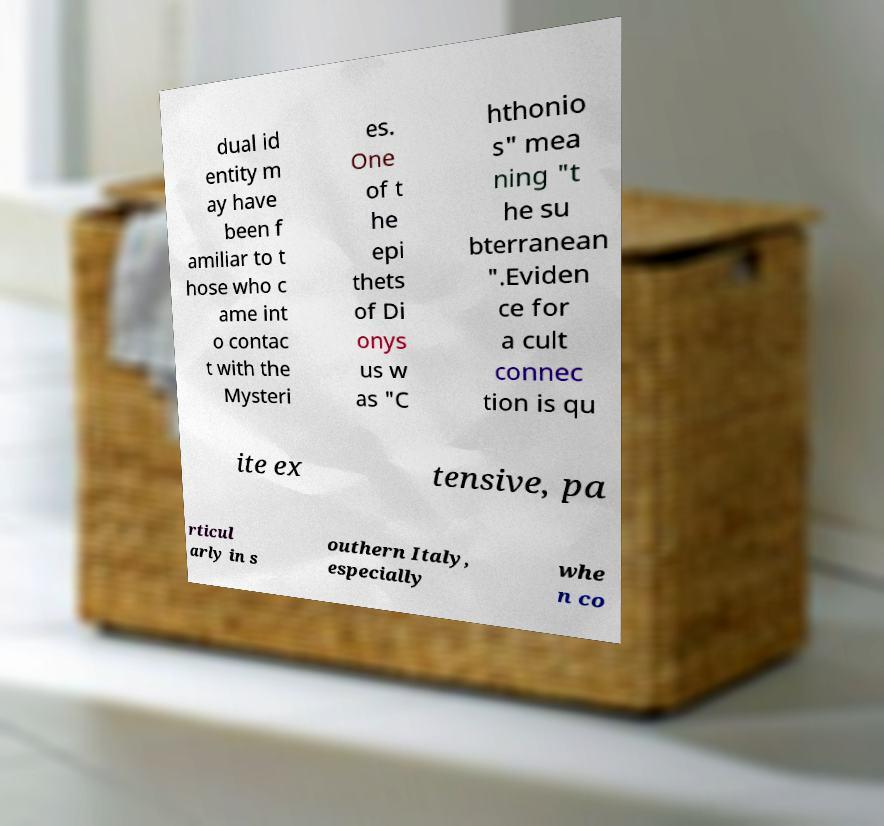Could you extract and type out the text from this image? dual id entity m ay have been f amiliar to t hose who c ame int o contac t with the Mysteri es. One of t he epi thets of Di onys us w as "C hthonio s" mea ning "t he su bterranean ".Eviden ce for a cult connec tion is qu ite ex tensive, pa rticul arly in s outhern Italy, especially whe n co 